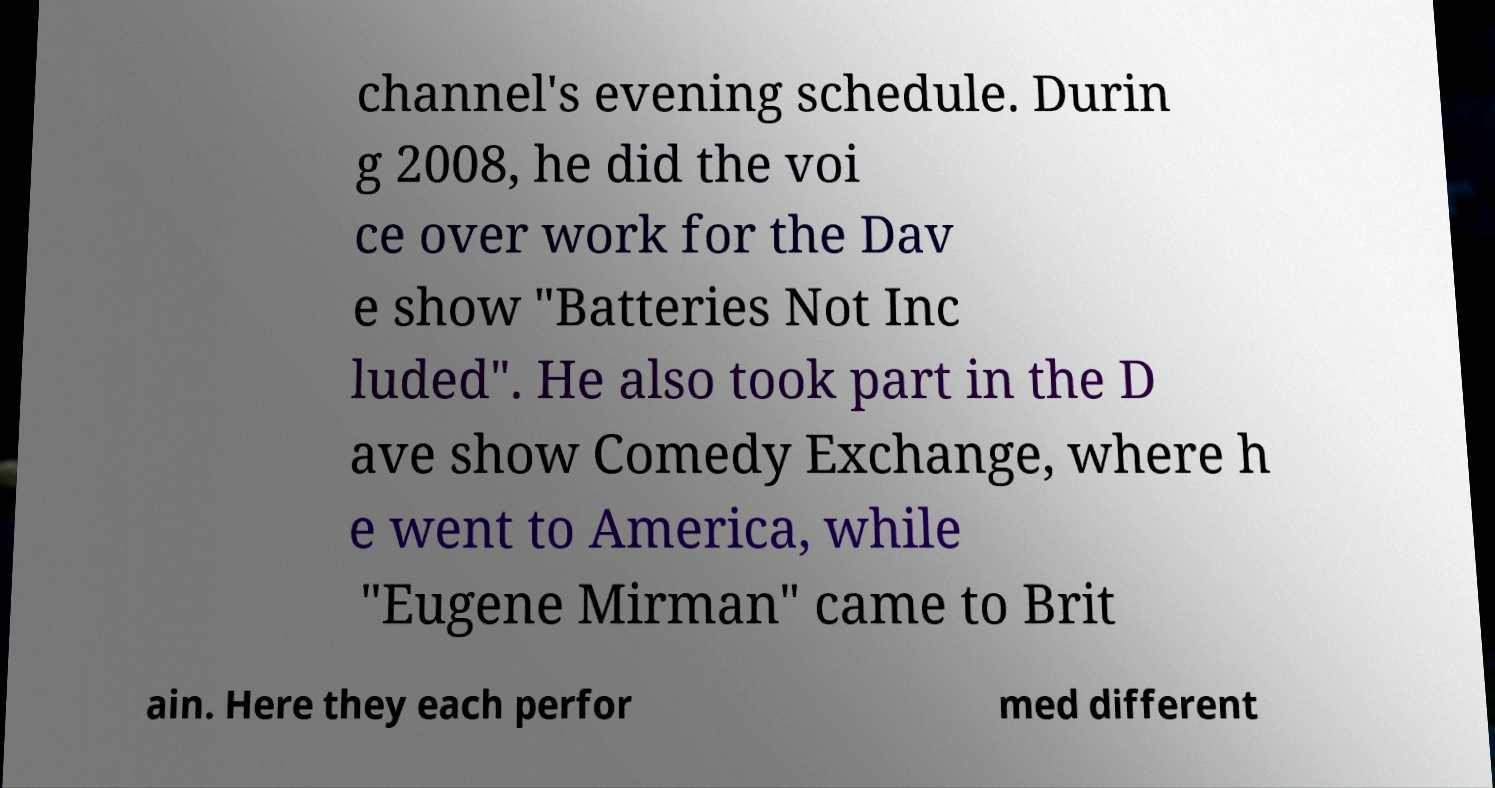Could you assist in decoding the text presented in this image and type it out clearly? channel's evening schedule. Durin g 2008, he did the voi ce over work for the Dav e show "Batteries Not Inc luded". He also took part in the D ave show Comedy Exchange, where h e went to America, while "Eugene Mirman" came to Brit ain. Here they each perfor med different 